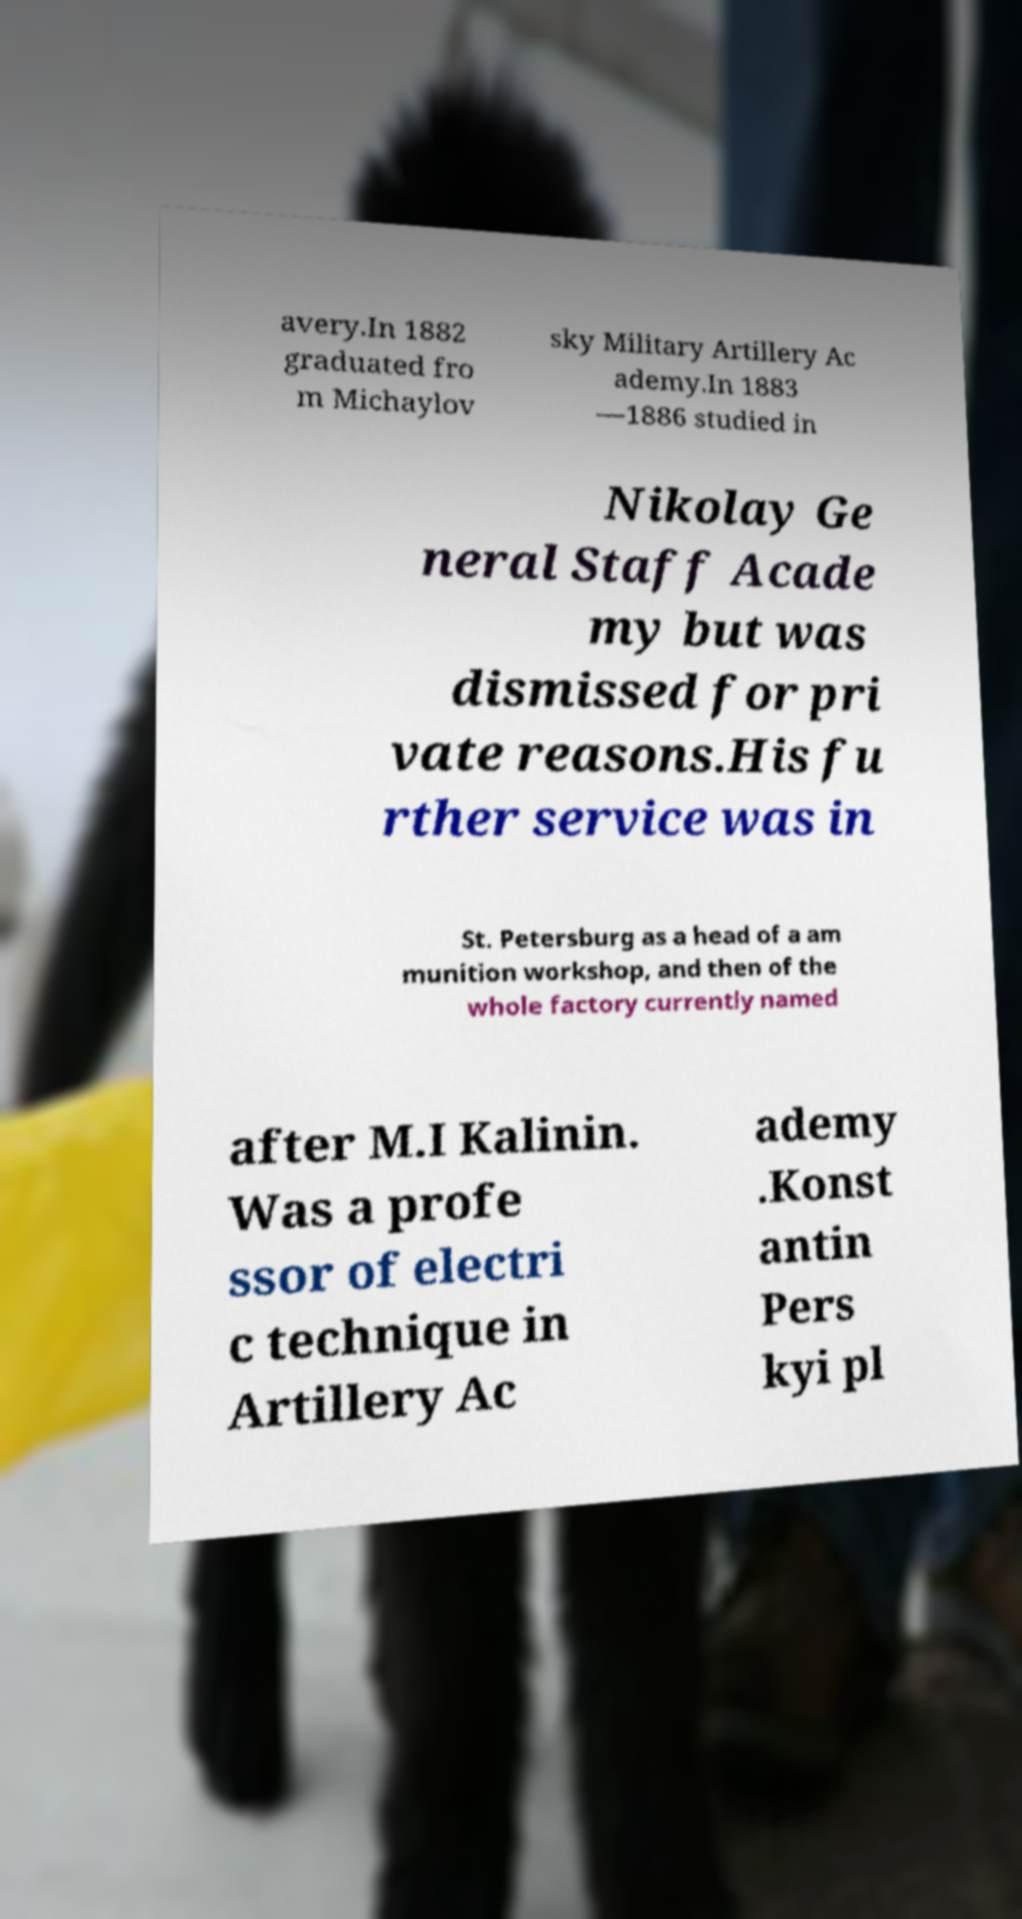There's text embedded in this image that I need extracted. Can you transcribe it verbatim? avery.In 1882 graduated fro m Michaylov sky Military Artillery Ac ademy.In 1883 —1886 studied in Nikolay Ge neral Staff Acade my but was dismissed for pri vate reasons.His fu rther service was in St. Petersburg as a head of a am munition workshop, and then of the whole factory currently named after M.I Kalinin. Was a profe ssor of electri c technique in Artillery Ac ademy .Konst antin Pers kyi pl 